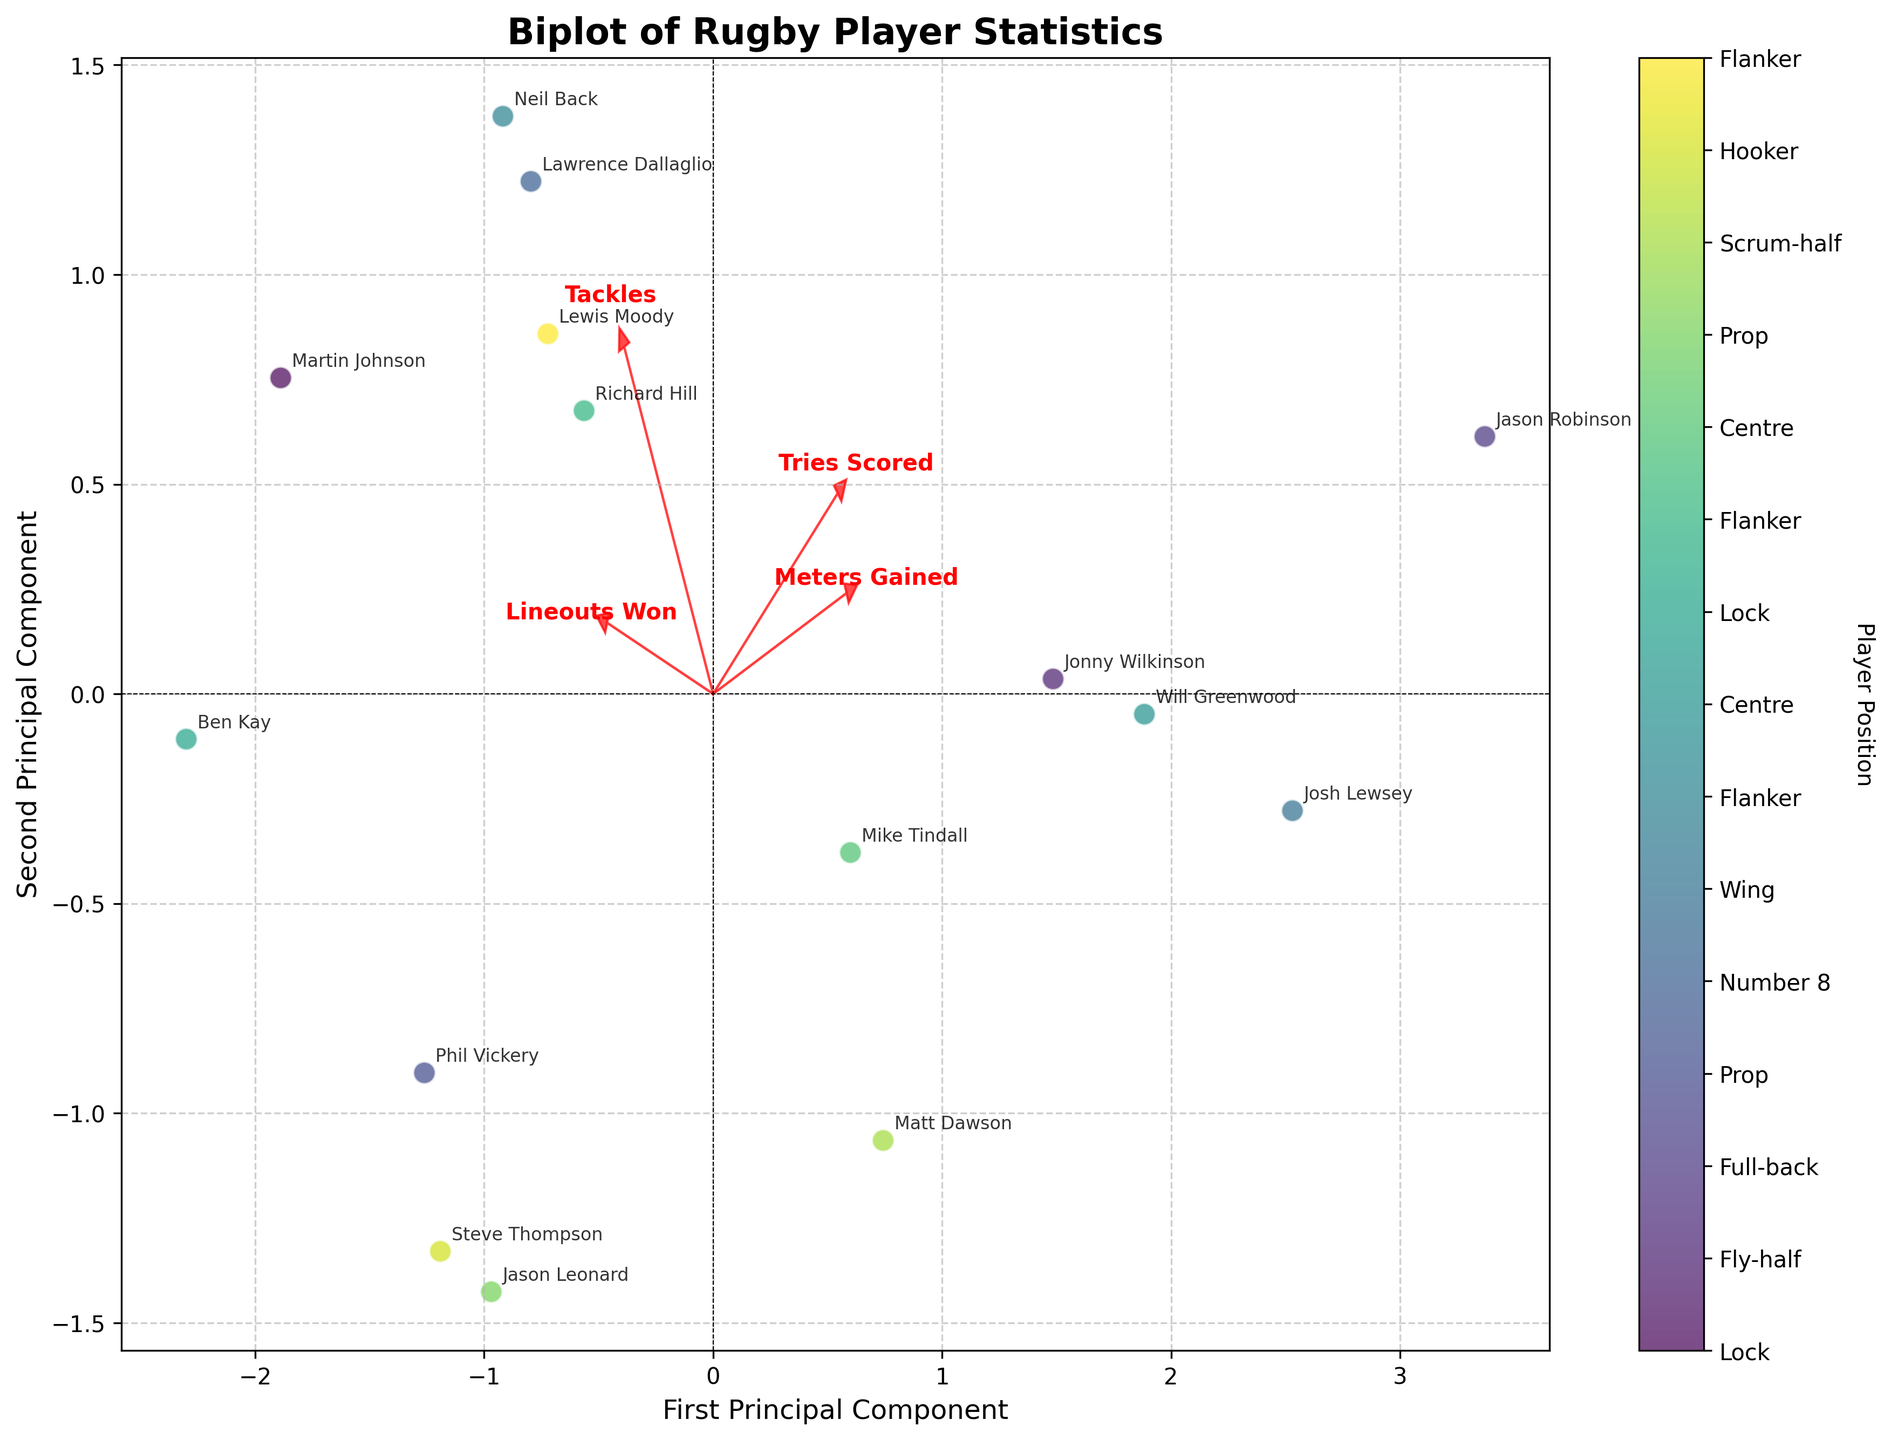Who has the highest scores along the first principal component? To determine the highest scores along the first principal component, look at the data points along the x-axis. The farther to the right a point is, the higher the score. Jason Robinson and Josh Lewsey appear to be the farthest, indicating they have the highest scores in the first principal component.
Answer: Jason Robinson, Josh Lewsey Which component is highly associated with 'Meters Gained'? The direction of the 'Meters Gained' arrow on the biplot shows its association. It points strongly towards the right of the x-axis, indicating a high association with the first principal component.
Answer: First principal component Which players have notable contributions in 'Lineouts Won'? Look at the direction and length of the 'Lineouts Won' arrow, which influences players aligned closely with it. Martin Johnson and Ben Kay seem closest to this vector, indicating significant contributions.
Answer: Martin Johnson, Ben Kay Is 'Tries Scored' more associated with the first or second principal component? The direction of the 'Tries Scored' arrow shows its association. It points upward and to the right, but more vertically aligned, indicating it has a higher association with the second principal component.
Answer: Second principal component Which players are positioned close to 'Tackles'? To find players associated with 'Tackles', observe those positioned in the direction and closer to the 'Tackles' arrow. Neil Back and Richard Hill appear close to this vector.
Answer: Neil Back, Richard Hill What does the spread of the data tell us about the variety in player statistics? The spread of points in the biplot shows how diversified and dispersed the players' stats are across the principal components. A more spread-out distribution indicates various skills and performances among the players.
Answer: Various skills and performances Are 'Tackles' and 'Lineouts Won' positively correlated? Examine the direction of the 'Tackles' and 'Lineouts Won' arrows. They both point to positive coordinates, indicating a positive correlation between these two variables.
Answer: Yes Which player had close projections along 'Tries Scored' and 'Meters Gained'? Observe players near the direction of both 'Tries Scored' and 'Meters Gained' vectors. Will Greenwood and Jonny Wilkinson are close to this combined direction.
Answer: Will Greenwood, Jonny Wilkinson Which principal component is most influenced by 'Tackles' and 'Lineouts Won' taken together? Look at the arrows of 'Tackles' and 'Lineouts Won'. Both point in similar directions but diagonally, suggesting an influence on both components. However, 'Tackles' points more towards the x-axis (first principal component), indicating a dominant influence there.
Answer: First principal component 